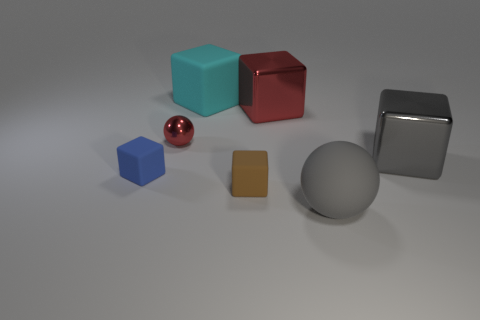Subtract all big cyan matte cubes. How many cubes are left? 4 Subtract all blue cubes. How many cubes are left? 4 Subtract all yellow blocks. Subtract all brown balls. How many blocks are left? 5 Add 2 gray matte balls. How many objects exist? 9 Subtract all cubes. How many objects are left? 2 Add 7 tiny red metal things. How many tiny red metal things are left? 8 Add 3 big matte things. How many big matte things exist? 5 Subtract 1 blue cubes. How many objects are left? 6 Subtract all red cylinders. Subtract all big balls. How many objects are left? 6 